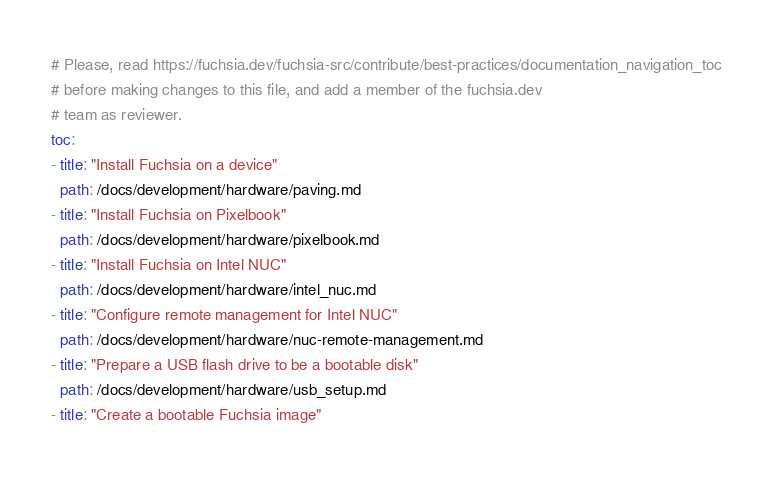Convert code to text. <code><loc_0><loc_0><loc_500><loc_500><_YAML_># Please, read https://fuchsia.dev/fuchsia-src/contribute/best-practices/documentation_navigation_toc
# before making changes to this file, and add a member of the fuchsia.dev
# team as reviewer.
toc:
- title: "Install Fuchsia on a device"
  path: /docs/development/hardware/paving.md
- title: "Install Fuchsia on Pixelbook"
  path: /docs/development/hardware/pixelbook.md
- title: "Install Fuchsia on Intel NUC"
  path: /docs/development/hardware/intel_nuc.md
- title: "Configure remote management for Intel NUC"
  path: /docs/development/hardware/nuc-remote-management.md
- title: "Prepare a USB flash drive to be a bootable disk"
  path: /docs/development/hardware/usb_setup.md
- title: "Create a bootable Fuchsia image"</code> 